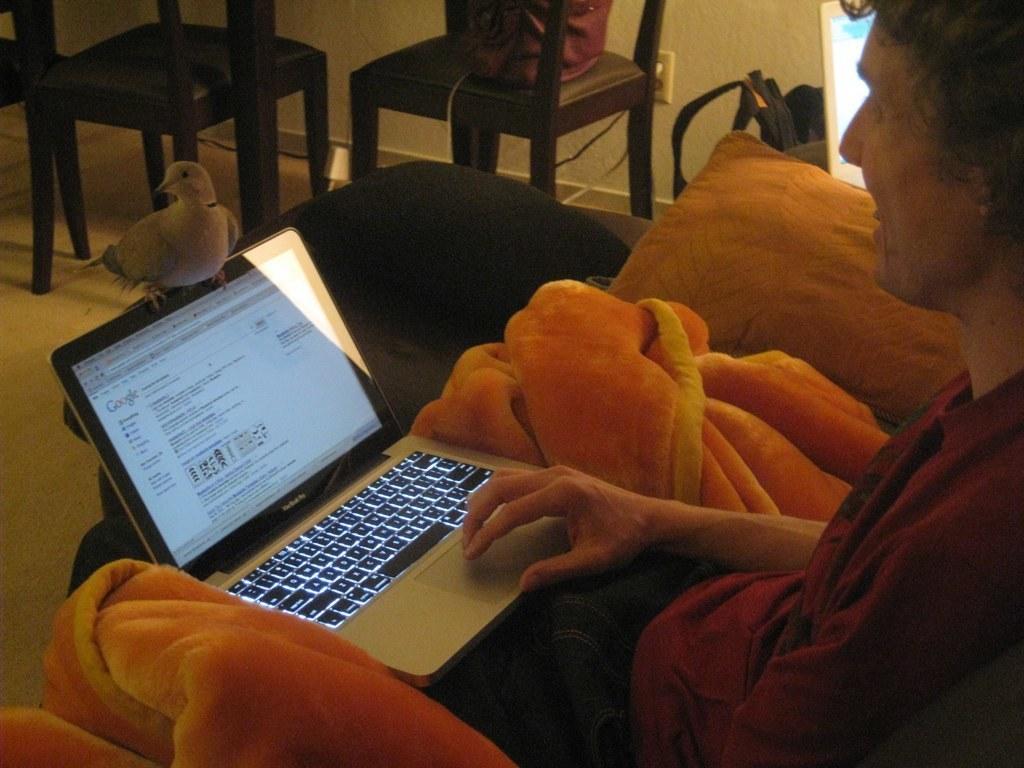Please provide a concise description of this image. This picture shows a man seated and holds a laptop in his hand and there is a bird on the laptop and we see couple of chairs and a pillow 